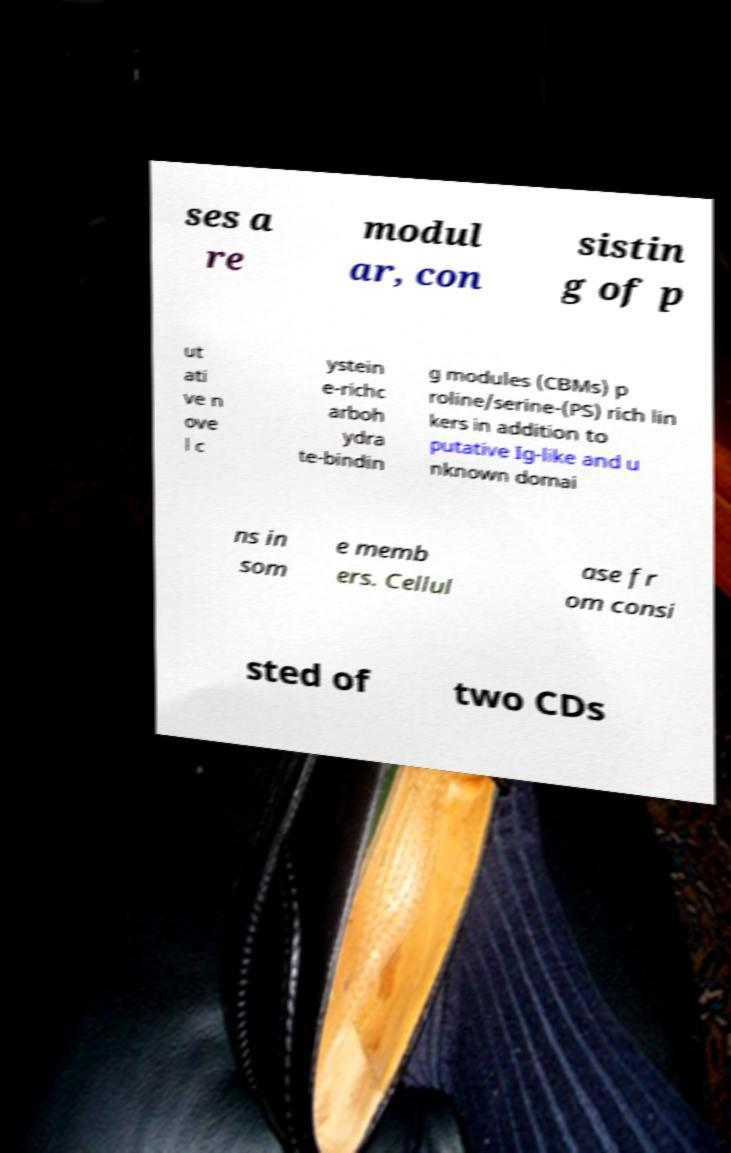Could you assist in decoding the text presented in this image and type it out clearly? ses a re modul ar, con sistin g of p ut ati ve n ove l c ystein e-richc arboh ydra te-bindin g modules (CBMs) p roline/serine-(PS) rich lin kers in addition to putative Ig-like and u nknown domai ns in som e memb ers. Cellul ase fr om consi sted of two CDs 